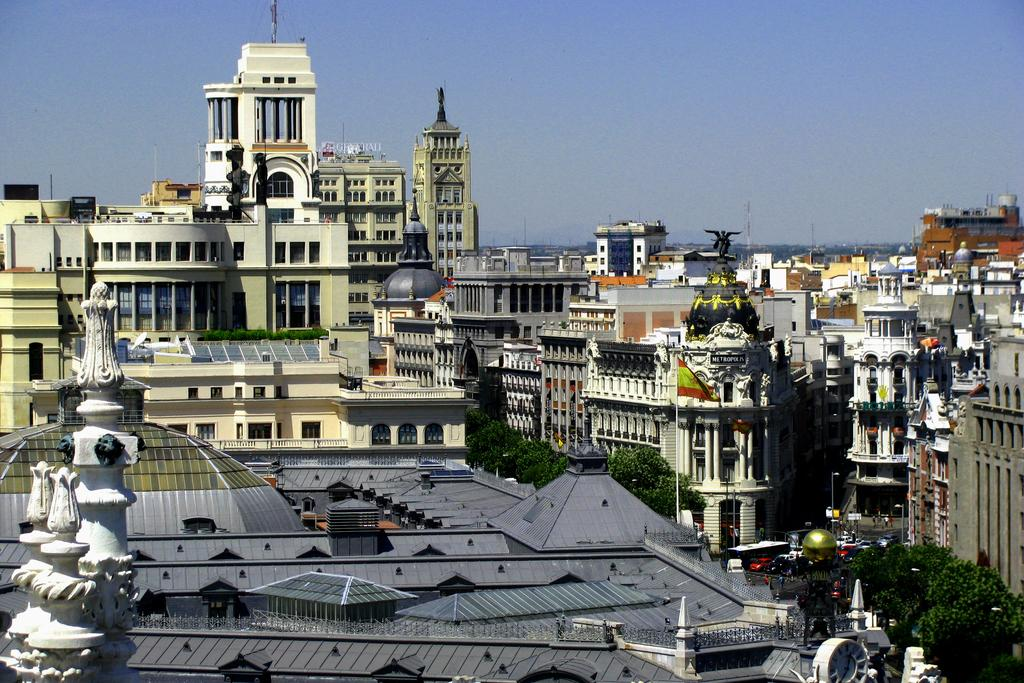What type of structures can be seen in the image? There are buildings in the image. What natural elements are present in the image? Trees are present in the image. Are there any living beings visible in the image? Yes, there are people in the image. What type of pathway is visible in the image? There is a road in the image. What are the tall, thin objects in the image? Poles are visible in the image. What is visible above the buildings and trees in the image? The sky is visible in the image. What type of orange crate can be seen in the image? There is no orange crate present in the image. What type of silk clothing is visible on the people in the image? There is no silk clothing visible on the people in the image. 